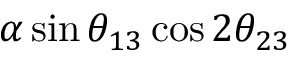<formula> <loc_0><loc_0><loc_500><loc_500>\alpha \sin { \theta _ { 1 3 } } \cos 2 { \theta _ { 2 3 } }</formula> 